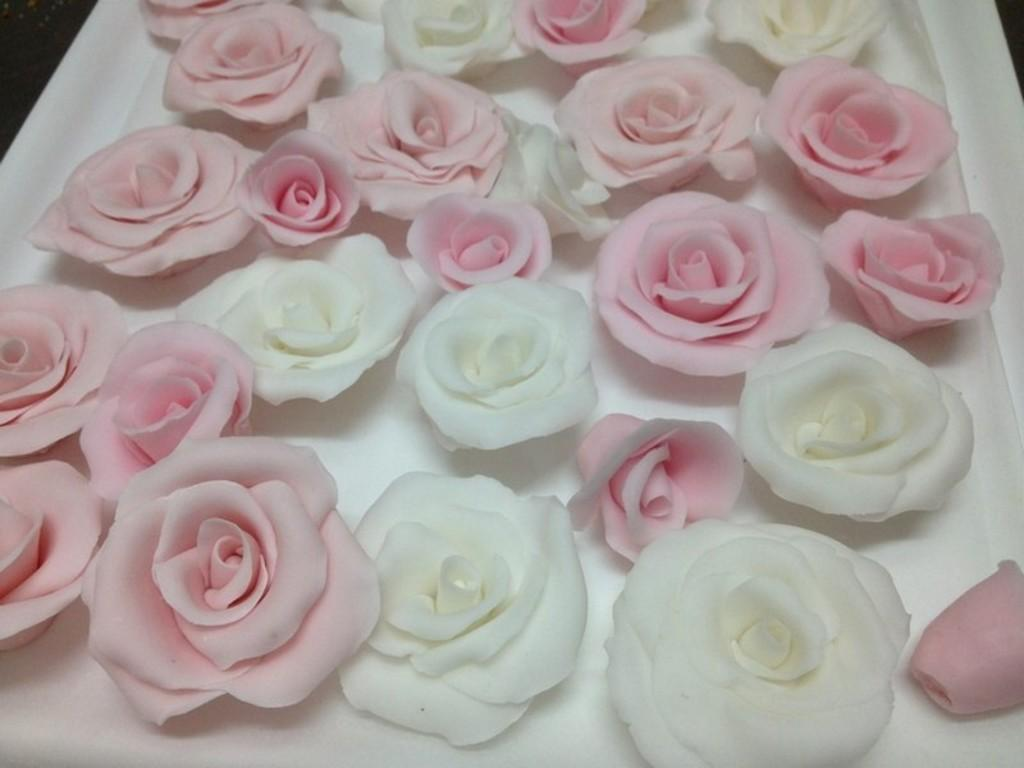What type of flowers are in the image? There are rose flowers in the image. What colors are the rose flowers? The rose flowers are pink and white in color. On what object are the rose flowers placed? The information provided does not specify the object on which the rose flowers are placed. How does the pollution affect the rose flowers in the image? There is no mention of pollution in the image, so it cannot be determined how it might affect the rose flowers. 